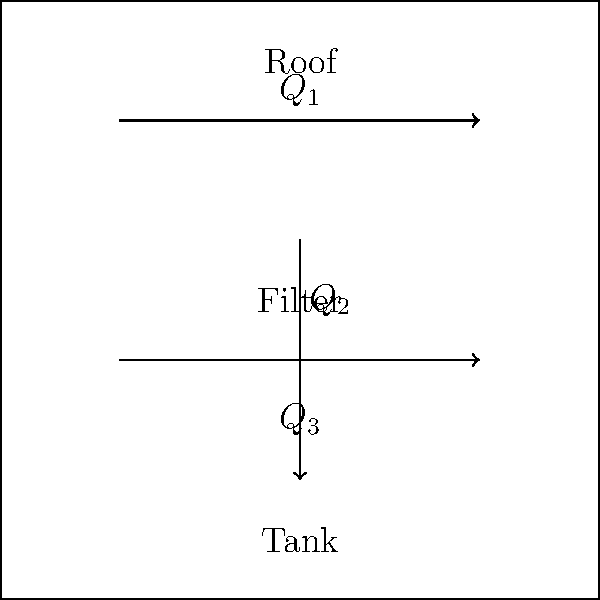In an eco-village rainwater harvesting system, water flows from the roof to a filter and then to a storage tank. The flow rate from the roof ($Q_1$) is 15 L/min. The filter removes 20% of the water for cleaning purposes ($Q_2$). Calculate the flow rate into the storage tank ($Q_3$) in L/min. To solve this problem, we'll follow these steps:

1. Identify the given information:
   - Flow rate from the roof ($Q_1$) = 15 L/min
   - Filter removes 20% of the water

2. Calculate the amount of water removed by the filter ($Q_2$):
   $Q_2 = 20\% \times Q_1 = 0.20 \times 15 \text{ L/min} = 3 \text{ L/min}$

3. Apply the conservation of mass principle:
   $Q_3 = Q_1 - Q_2$

4. Calculate the flow rate into the storage tank ($Q_3$):
   $Q_3 = 15 \text{ L/min} - 3 \text{ L/min} = 12 \text{ L/min}$

Therefore, the flow rate into the storage tank ($Q_3$) is 12 L/min.
Answer: 12 L/min 